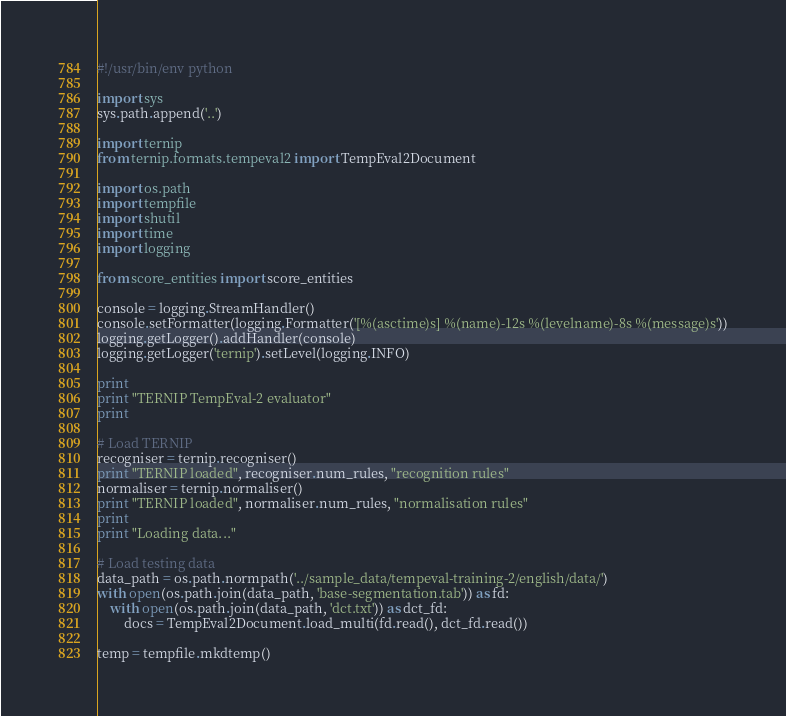<code> <loc_0><loc_0><loc_500><loc_500><_Python_>#!/usr/bin/env python

import sys
sys.path.append('..')

import ternip
from ternip.formats.tempeval2 import TempEval2Document

import os.path
import tempfile
import shutil
import time
import logging

from score_entities import score_entities

console = logging.StreamHandler()
console.setFormatter(logging.Formatter('[%(asctime)s] %(name)-12s %(levelname)-8s %(message)s'))
logging.getLogger().addHandler(console)
logging.getLogger('ternip').setLevel(logging.INFO)

print
print "TERNIP TempEval-2 evaluator"
print

# Load TERNIP
recogniser = ternip.recogniser()
print "TERNIP loaded", recogniser.num_rules, "recognition rules"
normaliser = ternip.normaliser()
print "TERNIP loaded", normaliser.num_rules, "normalisation rules"
print
print "Loading data..."

# Load testing data
data_path = os.path.normpath('../sample_data/tempeval-training-2/english/data/')
with open(os.path.join(data_path, 'base-segmentation.tab')) as fd:
    with open(os.path.join(data_path, 'dct.txt')) as dct_fd:
        docs = TempEval2Document.load_multi(fd.read(), dct_fd.read())

temp = tempfile.mkdtemp()
</code> 